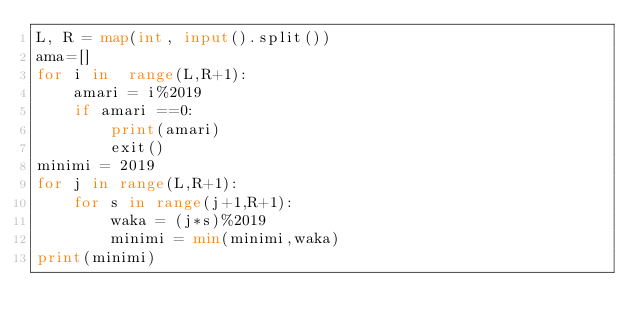<code> <loc_0><loc_0><loc_500><loc_500><_Python_>L, R = map(int, input().split())
ama=[]
for i in  range(L,R+1):
    amari = i%2019
    if amari ==0:
        print(amari)
        exit()
minimi = 2019
for j in range(L,R+1):
    for s in range(j+1,R+1):
        waka = (j*s)%2019
        minimi = min(minimi,waka)
print(minimi)</code> 